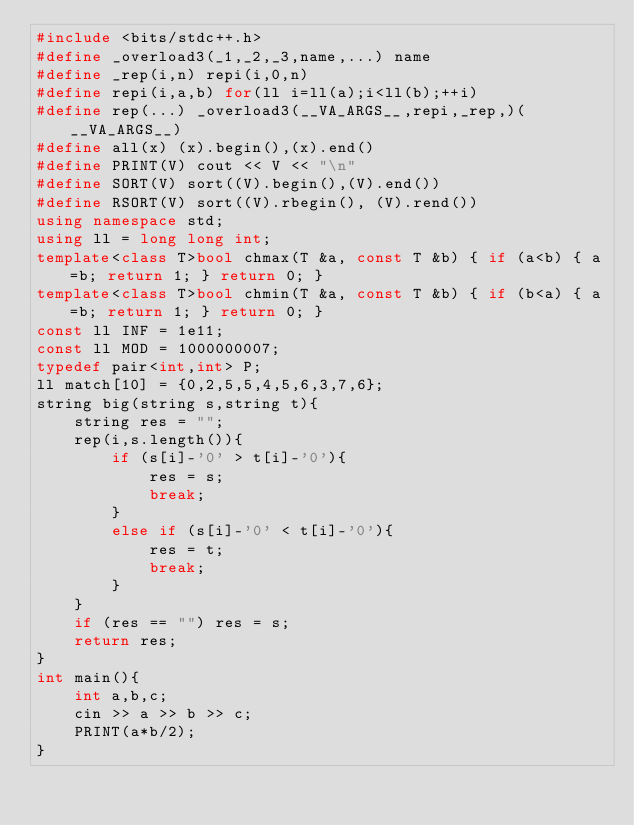Convert code to text. <code><loc_0><loc_0><loc_500><loc_500><_C++_>#include <bits/stdc++.h>
#define _overload3(_1,_2,_3,name,...) name
#define _rep(i,n) repi(i,0,n)
#define repi(i,a,b) for(ll i=ll(a);i<ll(b);++i)
#define rep(...) _overload3(__VA_ARGS__,repi,_rep,)(__VA_ARGS__)
#define all(x) (x).begin(),(x).end()
#define PRINT(V) cout << V << "\n"
#define SORT(V) sort((V).begin(),(V).end())
#define RSORT(V) sort((V).rbegin(), (V).rend())
using namespace std;
using ll = long long int;
template<class T>bool chmax(T &a, const T &b) { if (a<b) { a=b; return 1; } return 0; }
template<class T>bool chmin(T &a, const T &b) { if (b<a) { a=b; return 1; } return 0; }
const ll INF = 1e11;
const ll MOD = 1000000007;
typedef pair<int,int> P;
ll match[10] = {0,2,5,5,4,5,6,3,7,6};
string big(string s,string t){
    string res = "";
    rep(i,s.length()){
        if (s[i]-'0' > t[i]-'0'){
            res = s;
            break;
        }
        else if (s[i]-'0' < t[i]-'0'){
            res = t;
            break;
        }
    }
    if (res == "") res = s;
    return res;
}
int main(){
    int a,b,c;
    cin >> a >> b >> c;
    PRINT(a*b/2);
}</code> 